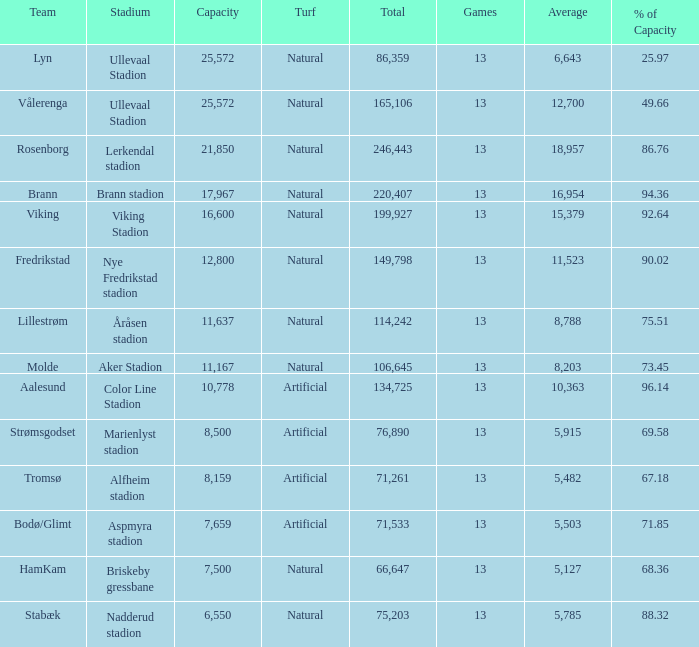What was the total attendance of aalesund which had a capacity with more than 96.14%? None. 